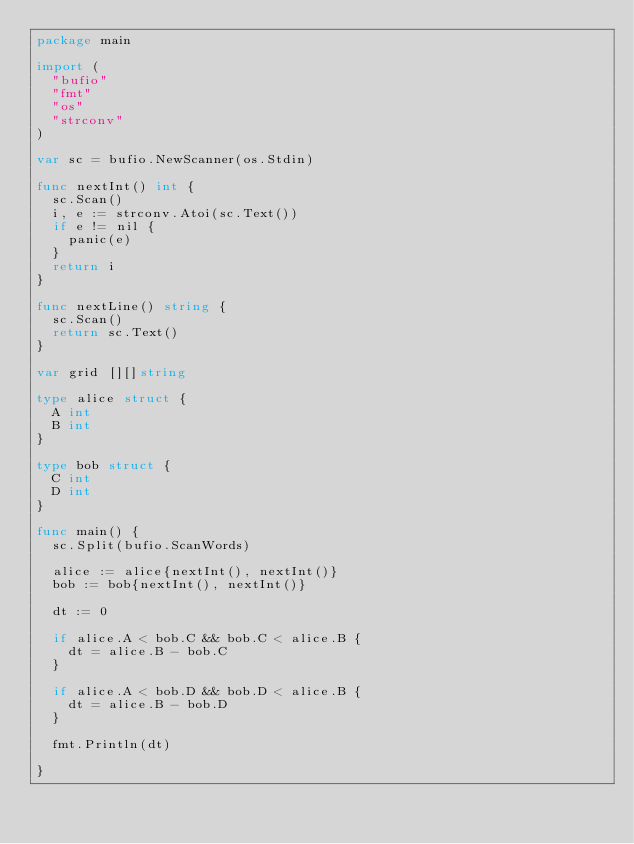Convert code to text. <code><loc_0><loc_0><loc_500><loc_500><_Go_>package main

import (
	"bufio"
	"fmt"
	"os"
	"strconv"
)

var sc = bufio.NewScanner(os.Stdin)

func nextInt() int {
	sc.Scan()
	i, e := strconv.Atoi(sc.Text())
	if e != nil {
		panic(e)
	}
	return i
}

func nextLine() string {
	sc.Scan()
	return sc.Text()
}

var grid [][]string

type alice struct {
	A int
	B int
}

type bob struct {
	C int
	D int
}

func main() {
	sc.Split(bufio.ScanWords)

	alice := alice{nextInt(), nextInt()}
	bob := bob{nextInt(), nextInt()}

	dt := 0

	if alice.A < bob.C && bob.C < alice.B {
		dt = alice.B - bob.C
	}

	if alice.A < bob.D && bob.D < alice.B {
		dt = alice.B - bob.D
	}

	fmt.Println(dt)

}
</code> 